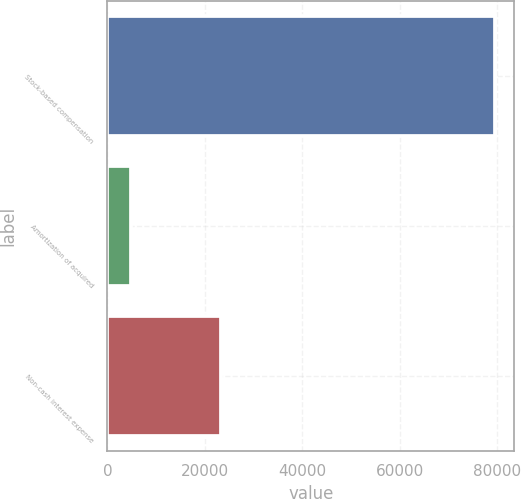Convert chart to OTSL. <chart><loc_0><loc_0><loc_500><loc_500><bar_chart><fcel>Stock-based compensation<fcel>Amortization of acquired<fcel>Non-cash interest expense<nl><fcel>79469<fcel>4876<fcel>23309<nl></chart> 